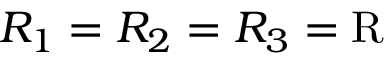<formula> <loc_0><loc_0><loc_500><loc_500>R _ { 1 } = R _ { 2 } = R _ { 3 } = R</formula> 